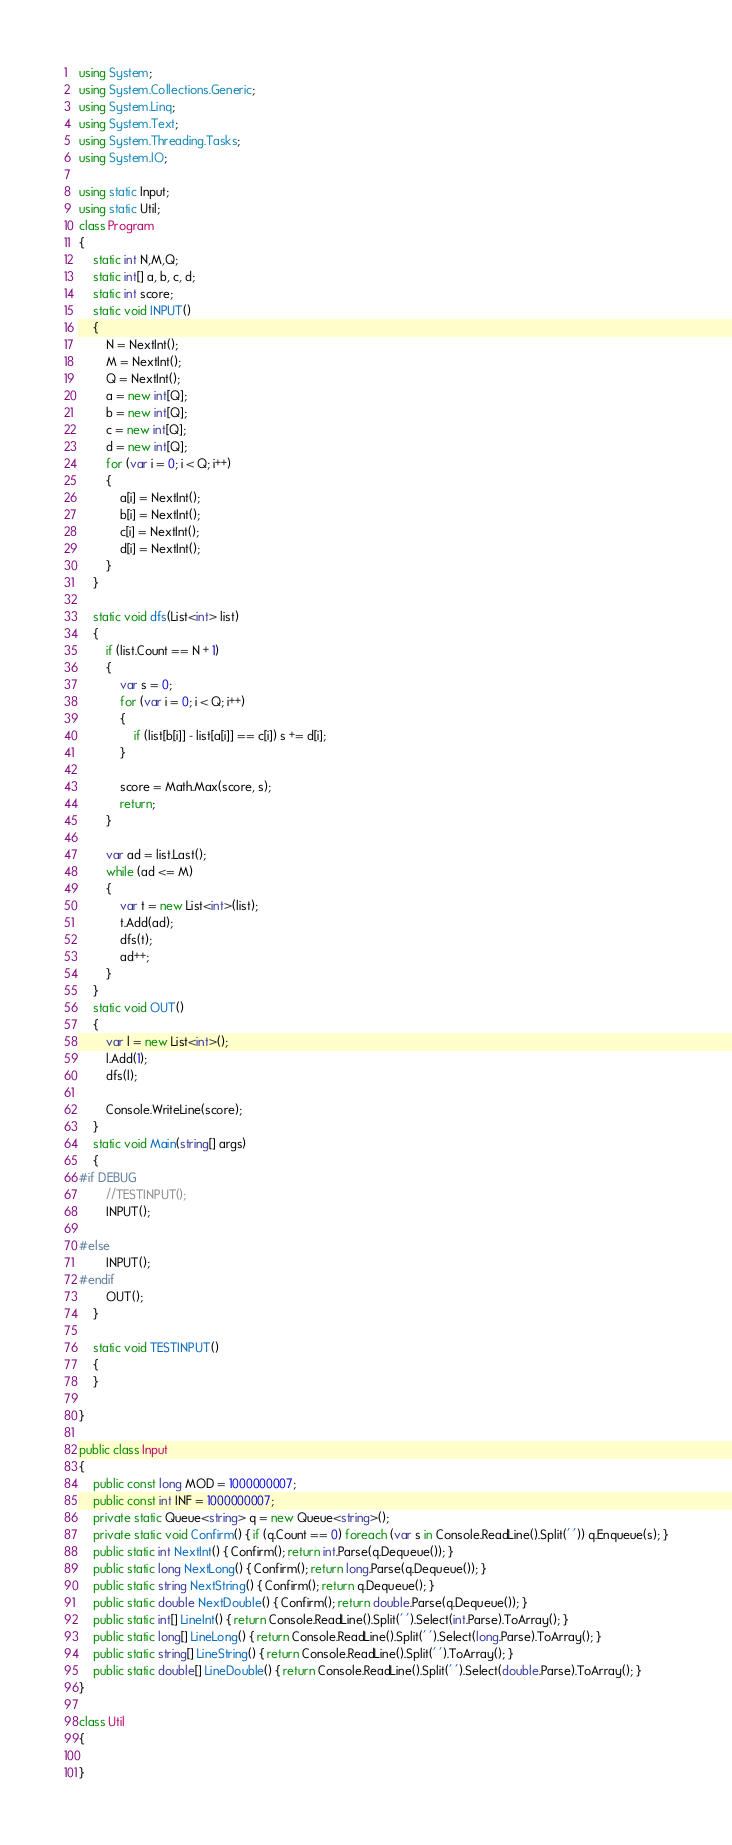Convert code to text. <code><loc_0><loc_0><loc_500><loc_500><_C#_>using System;
using System.Collections.Generic;
using System.Linq;
using System.Text;
using System.Threading.Tasks;
using System.IO;

using static Input;
using static Util;
class Program
{
    static int N,M,Q;
    static int[] a, b, c, d;
    static int score;
    static void INPUT()
    {
        N = NextInt();
        M = NextInt();
        Q = NextInt();
        a = new int[Q];
        b = new int[Q];
        c = new int[Q];
        d = new int[Q];
        for (var i = 0; i < Q; i++)
        {
            a[i] = NextInt();
            b[i] = NextInt();
            c[i] = NextInt();
            d[i] = NextInt();
        }
    }

    static void dfs(List<int> list)
    {
        if (list.Count == N + 1)
        {
            var s = 0;
            for (var i = 0; i < Q; i++)
            {
                if (list[b[i]] - list[a[i]] == c[i]) s += d[i];
            }

            score = Math.Max(score, s);
            return;
        }

        var ad = list.Last();
        while (ad <= M)
        {
            var t = new List<int>(list);
            t.Add(ad);
            dfs(t);
            ad++;
        }
    }
    static void OUT()
    {
        var l = new List<int>();
        l.Add(1);
        dfs(l);

        Console.WriteLine(score);
    }
    static void Main(string[] args)
    {
#if DEBUG  
        //TESTINPUT();
        INPUT();

#else
        INPUT();
#endif
        OUT();
    }

    static void TESTINPUT()
    {
    }

}

public class Input
{
    public const long MOD = 1000000007;
    public const int INF = 1000000007;
    private static Queue<string> q = new Queue<string>();
    private static void Confirm() { if (q.Count == 0) foreach (var s in Console.ReadLine().Split(' ')) q.Enqueue(s); }
    public static int NextInt() { Confirm(); return int.Parse(q.Dequeue()); }
    public static long NextLong() { Confirm(); return long.Parse(q.Dequeue()); }
    public static string NextString() { Confirm(); return q.Dequeue(); }
    public static double NextDouble() { Confirm(); return double.Parse(q.Dequeue()); }
    public static int[] LineInt() { return Console.ReadLine().Split(' ').Select(int.Parse).ToArray(); }
    public static long[] LineLong() { return Console.ReadLine().Split(' ').Select(long.Parse).ToArray(); }
    public static string[] LineString() { return Console.ReadLine().Split(' ').ToArray(); }
    public static double[] LineDouble() { return Console.ReadLine().Split(' ').Select(double.Parse).ToArray(); }
}

class Util
{

}


</code> 